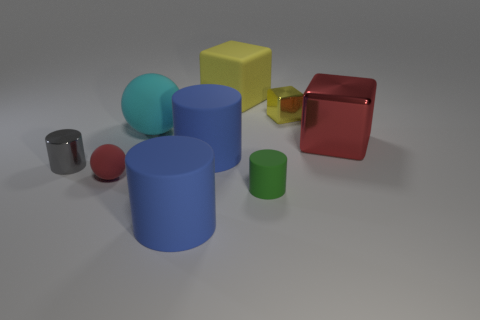What time of day does the lighting in this scene suggest? The lighting in the scene is neutral and does not strongly indicate a particular time of day. It could be artificial lighting, typical of an indoor photo shoot or a controlled environment like a studio. 